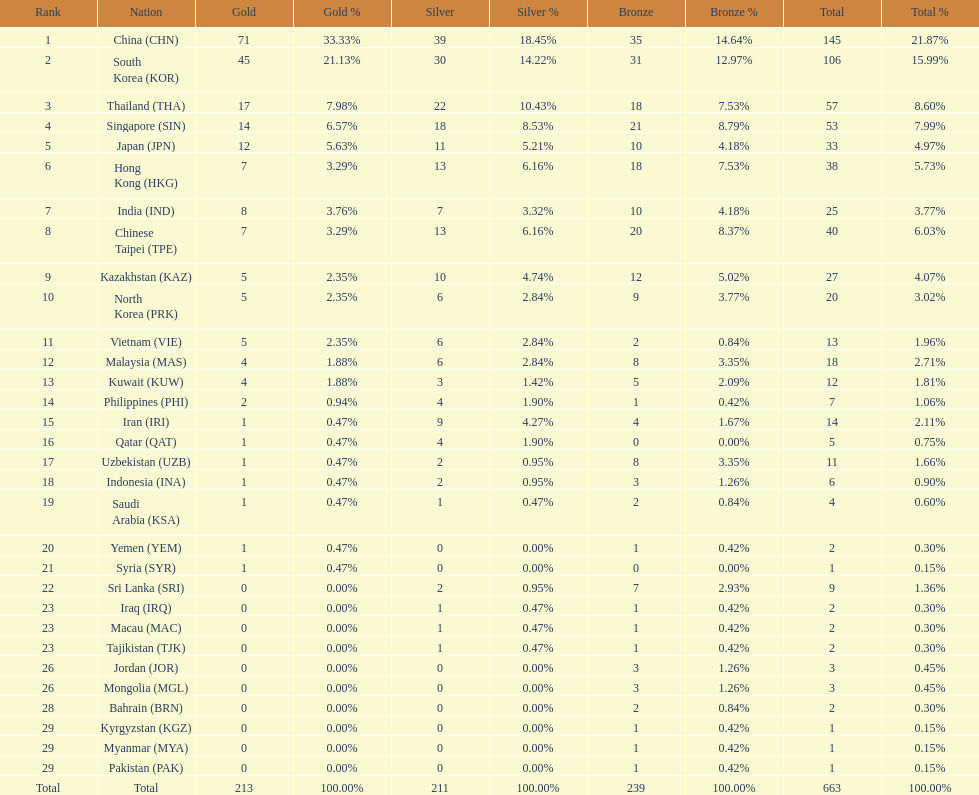What is the difference between the total amount of medals won by qatar and indonesia? 1. 